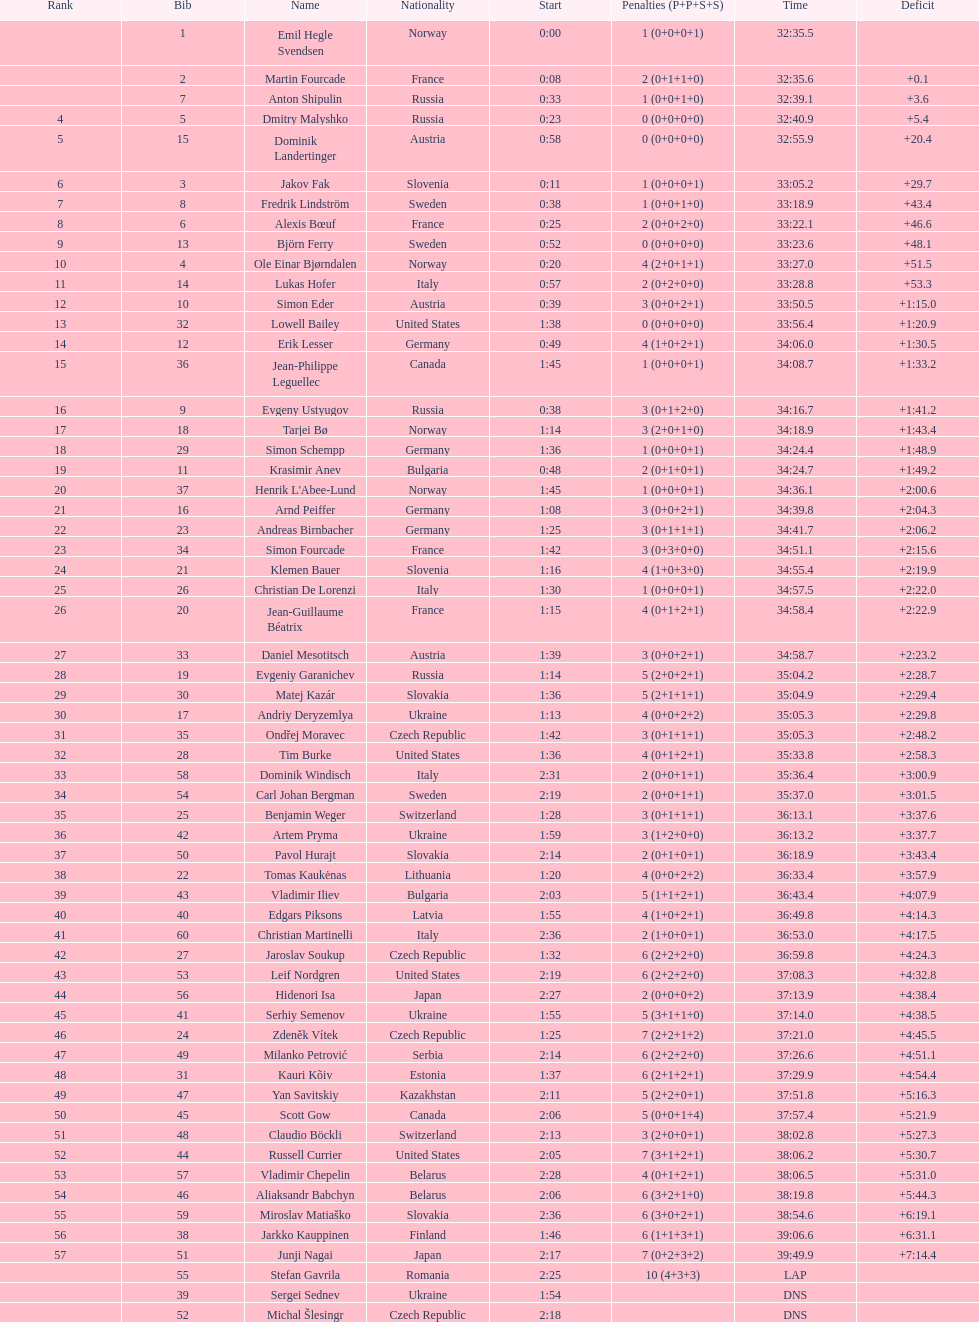Besides burke, can you mention another american athlete? Leif Nordgren. 